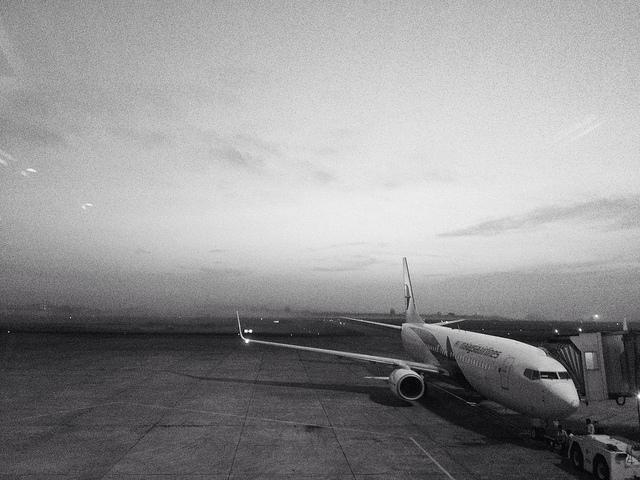What time is it on the image?
Choose the right answer from the provided options to respond to the question.
Options: Morning, afternoon, night, noon. Night. 